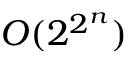<formula> <loc_0><loc_0><loc_500><loc_500>O ( 2 ^ { 2 ^ { n } } )</formula> 